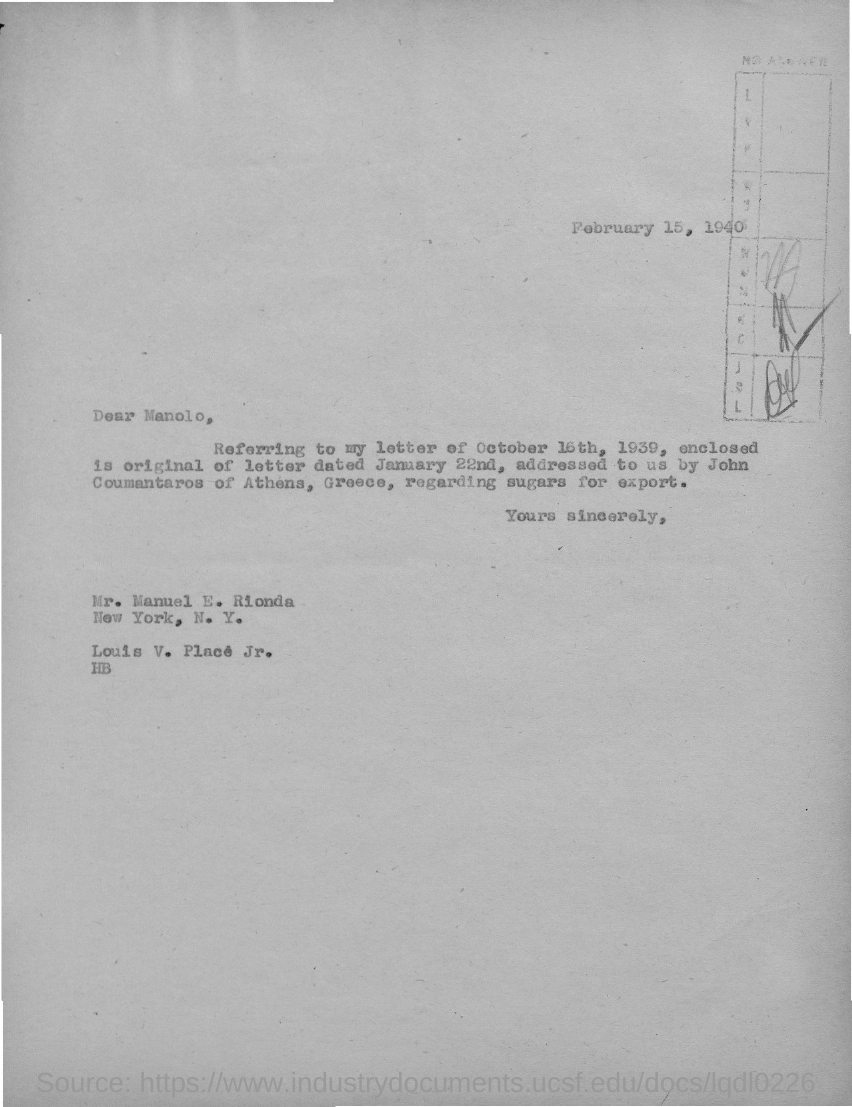Draw attention to some important aspects in this diagram. The letter is dated February 15, 1940. 